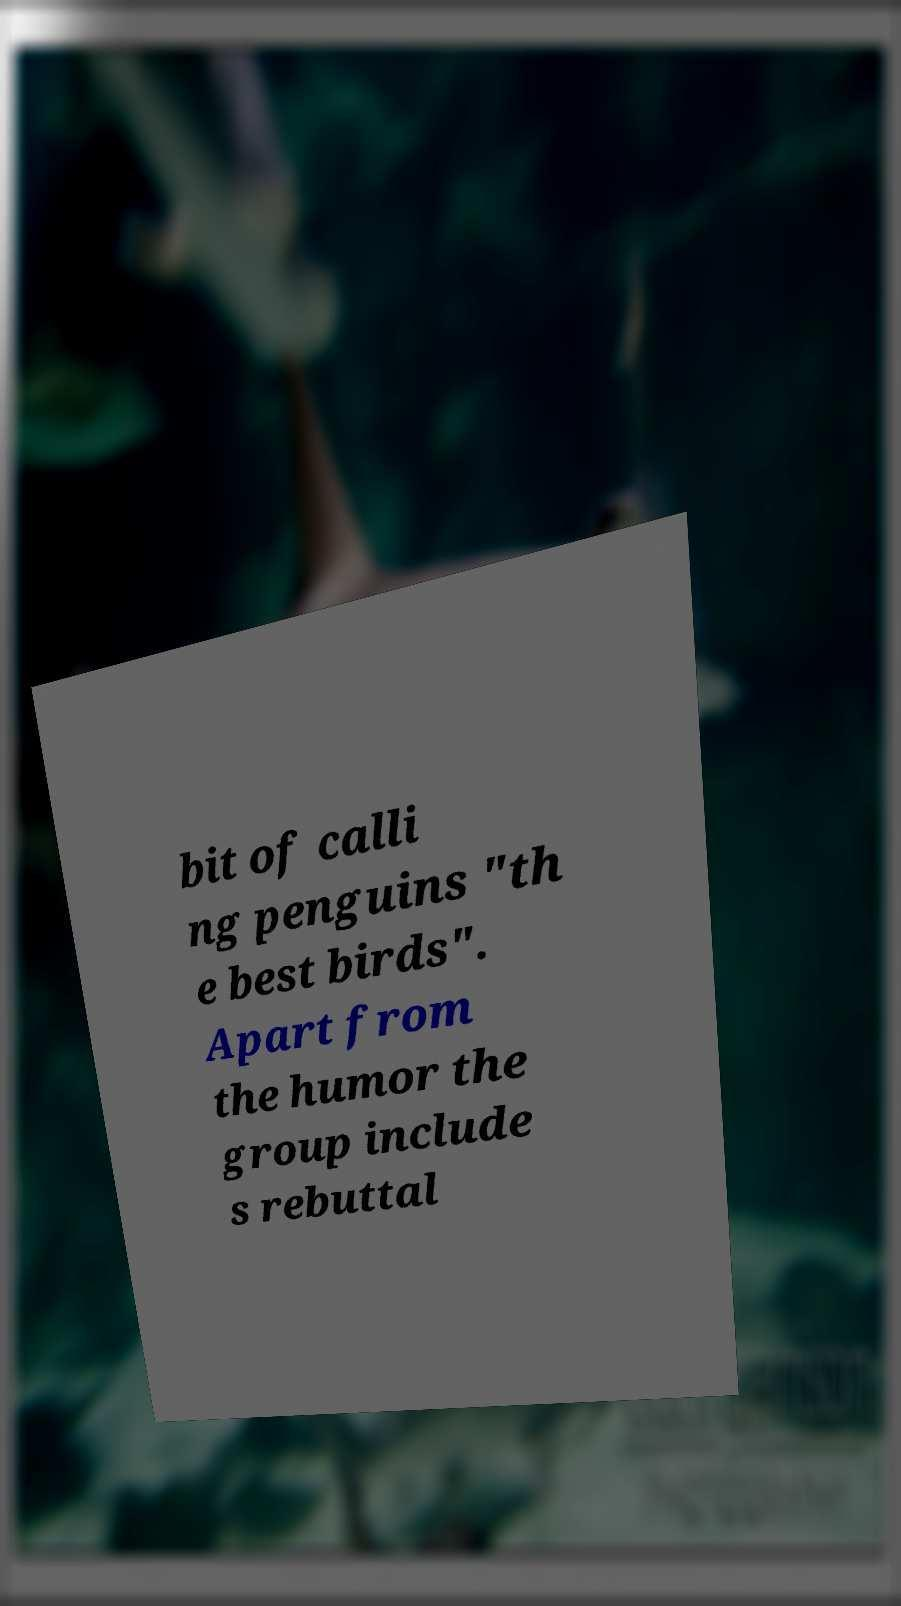Can you read and provide the text displayed in the image?This photo seems to have some interesting text. Can you extract and type it out for me? bit of calli ng penguins "th e best birds". Apart from the humor the group include s rebuttal 